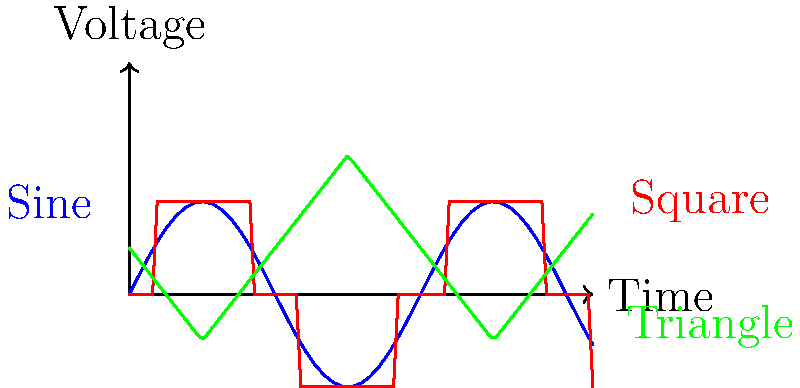As a linguist exploring the "dialects" of electrical signals, analyze the voltage vs. time waveforms shown in the graph. Which of these waveforms would be most suitable for representing a binary digital signal in a communication system, and why might this be analogous to the use of distinct phonemes in language? Let's approach this step-by-step, drawing parallels between signal types and linguistic concepts:

1. Sine wave (blue):
   - Smooth, continuous oscillation
   - Analogous to tonal languages where pitch changes convey meaning
   - Not ideal for binary digital signals due to its continuous nature

2. Triangle wave (green):
   - Linear transitions between peaks and troughs
   - Similar to language intonation patterns in sentences
   - Not ideal for binary digital signals due to multiple voltage levels

3. Square wave (red):
   - Abrupt transitions between two distinct voltage levels
   - Most suitable for binary digital signals
   - Analogous to distinct phonemes in language

The square wave is most suitable for representing a binary digital signal because:
a) It has two distinct voltage levels, easily interpretable as 0 and 1
b) Sharp transitions make it less susceptible to noise and interference
c) Timing of transitions can be precisely measured

This is analogous to phonemes in language because:
a) Phonemes are distinct sound units that differentiate meaning
b) Like binary digits, phonemes are typically perceived categorically
c) Clear distinctions between phonemes aid in accurate communication

Just as languages use a finite set of distinct phonemes to build complex meanings, digital systems use binary signals (0s and 1s) to encode and transmit complex information.
Answer: Square wave; represents distinct states like phonemes in language 